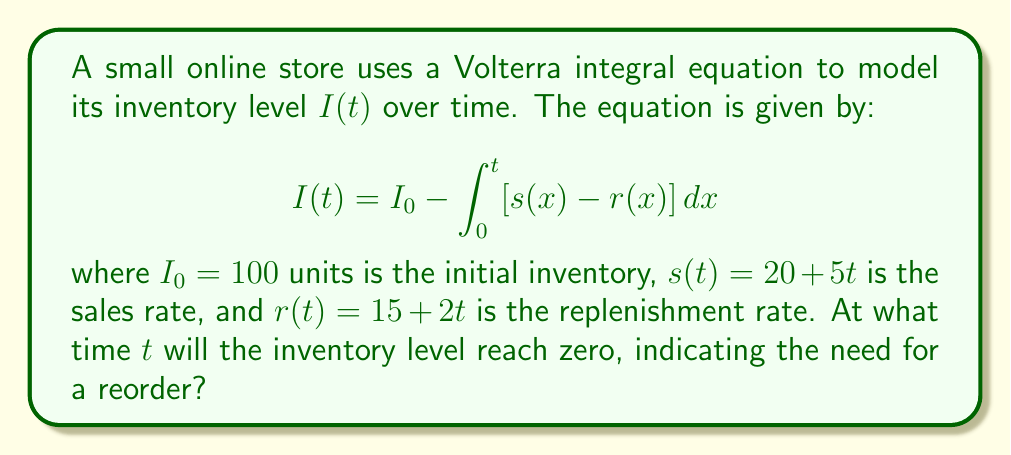Can you solve this math problem? To solve this problem, we'll follow these steps:

1) First, let's simplify the integrand:
   $s(x) - r(x) = (20 + 5x) - (15 + 2x) = 5 + 3x$

2) Now, our equation becomes:
   $$I(t) = 100 - \int_0^t (5 + 3x) dx$$

3) Let's solve the integral:
   $$I(t) = 100 - [5x + \frac{3x^2}{2}]_0^t = 100 - (5t + \frac{3t^2}{2})$$

4) We want to find when $I(t) = 0$:
   $$0 = 100 - (5t + \frac{3t^2}{2})$$

5) Rearrange the equation:
   $$\frac{3t^2}{2} + 5t - 100 = 0$$

6) Multiply everything by 2 to simplify:
   $$3t^2 + 10t - 200 = 0$$

7) This is a quadratic equation. We can solve it using the quadratic formula:
   $$t = \frac{-b \pm \sqrt{b^2 - 4ac}}{2a}$$
   where $a = 3$, $b = 10$, and $c = -200$

8) Plugging in these values:
   $$t = \frac{-10 \pm \sqrt{100 + 2400}}{6} = \frac{-10 \pm \sqrt{2500}}{6} = \frac{-10 \pm 50}{6}$$

9) This gives us two solutions:
   $$t = \frac{-10 + 50}{6} = \frac{40}{6} \approx 6.67$$
   $$t = \frac{-10 - 50}{6} = -10$$

10) Since time can't be negative in this context, we take the positive solution.

Therefore, the inventory will reach zero after approximately 6.67 time units.
Answer: 6.67 time units 